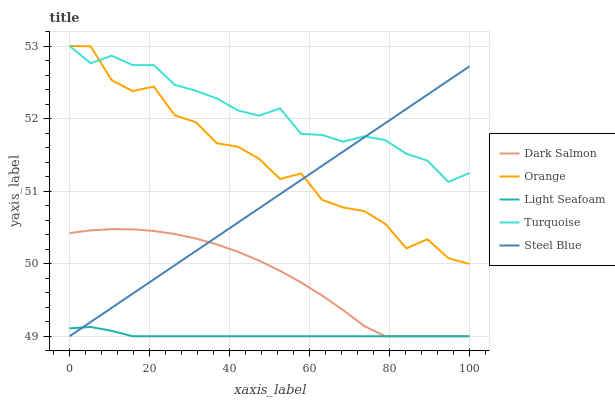Does Light Seafoam have the minimum area under the curve?
Answer yes or no. Yes. Does Turquoise have the maximum area under the curve?
Answer yes or no. Yes. Does Turquoise have the minimum area under the curve?
Answer yes or no. No. Does Light Seafoam have the maximum area under the curve?
Answer yes or no. No. Is Steel Blue the smoothest?
Answer yes or no. Yes. Is Orange the roughest?
Answer yes or no. Yes. Is Turquoise the smoothest?
Answer yes or no. No. Is Turquoise the roughest?
Answer yes or no. No. Does Turquoise have the lowest value?
Answer yes or no. No. Does Turquoise have the highest value?
Answer yes or no. Yes. Does Light Seafoam have the highest value?
Answer yes or no. No. Is Dark Salmon less than Orange?
Answer yes or no. Yes. Is Turquoise greater than Light Seafoam?
Answer yes or no. Yes. Does Orange intersect Turquoise?
Answer yes or no. Yes. Is Orange less than Turquoise?
Answer yes or no. No. Is Orange greater than Turquoise?
Answer yes or no. No. Does Dark Salmon intersect Orange?
Answer yes or no. No. 